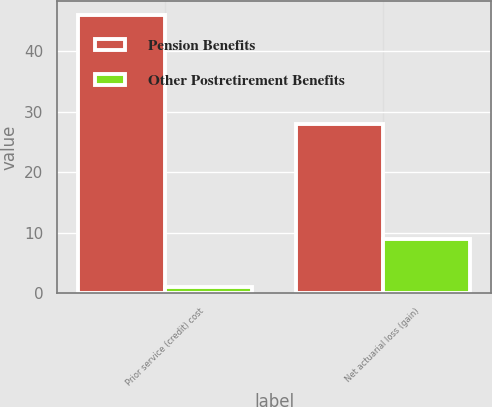Convert chart. <chart><loc_0><loc_0><loc_500><loc_500><stacked_bar_chart><ecel><fcel>Prior service (credit) cost<fcel>Net actuarial loss (gain)<nl><fcel>Pension Benefits<fcel>46<fcel>28<nl><fcel>Other Postretirement Benefits<fcel>1<fcel>9<nl></chart> 